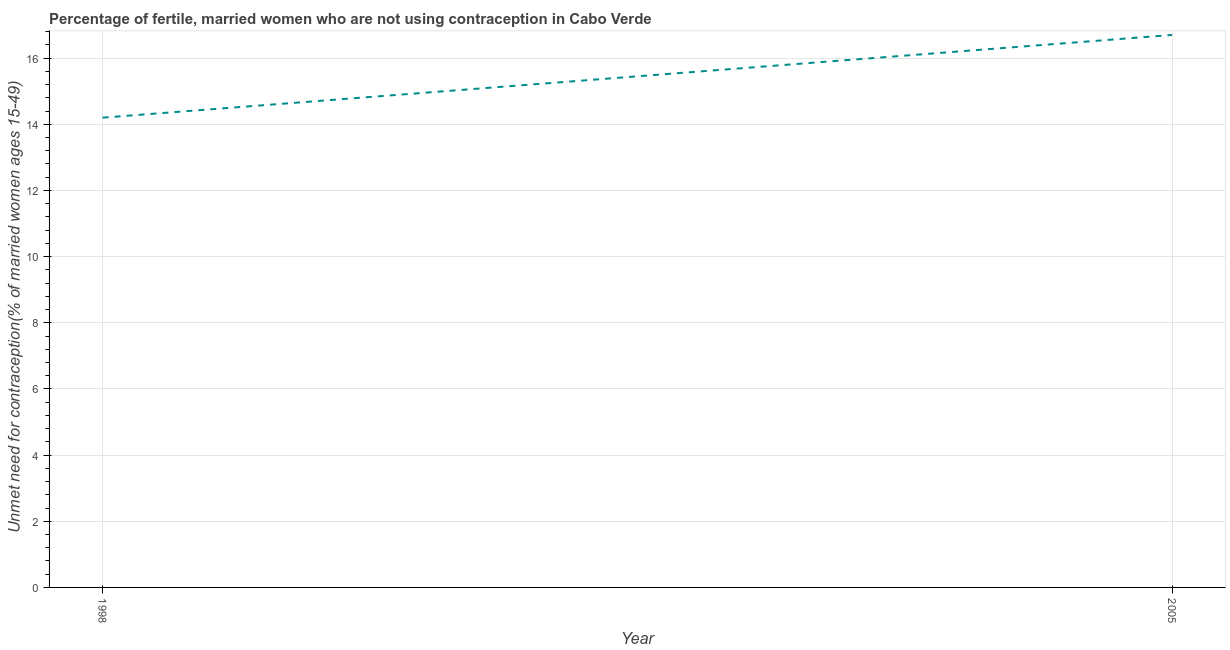What is the sum of the number of married women who are not using contraception?
Make the answer very short. 30.9. What is the average number of married women who are not using contraception per year?
Offer a terse response. 15.45. What is the median number of married women who are not using contraception?
Your answer should be compact. 15.45. Do a majority of the years between 1998 and 2005 (inclusive) have number of married women who are not using contraception greater than 12 %?
Offer a very short reply. Yes. What is the ratio of the number of married women who are not using contraception in 1998 to that in 2005?
Offer a terse response. 0.85. Is the number of married women who are not using contraception in 1998 less than that in 2005?
Provide a short and direct response. Yes. Does the number of married women who are not using contraception monotonically increase over the years?
Your response must be concise. Yes. How many lines are there?
Make the answer very short. 1. How many years are there in the graph?
Keep it short and to the point. 2. Are the values on the major ticks of Y-axis written in scientific E-notation?
Provide a succinct answer. No. Does the graph contain any zero values?
Offer a terse response. No. What is the title of the graph?
Your answer should be compact. Percentage of fertile, married women who are not using contraception in Cabo Verde. What is the label or title of the X-axis?
Your answer should be very brief. Year. What is the label or title of the Y-axis?
Make the answer very short.  Unmet need for contraception(% of married women ages 15-49). What is the  Unmet need for contraception(% of married women ages 15-49) of 2005?
Provide a short and direct response. 16.7. What is the difference between the  Unmet need for contraception(% of married women ages 15-49) in 1998 and 2005?
Your response must be concise. -2.5. What is the ratio of the  Unmet need for contraception(% of married women ages 15-49) in 1998 to that in 2005?
Ensure brevity in your answer.  0.85. 